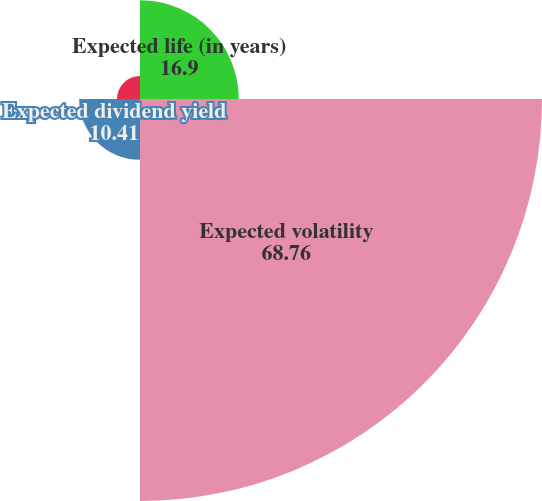<chart> <loc_0><loc_0><loc_500><loc_500><pie_chart><fcel>Expected life (in years)<fcel>Expected volatility<fcel>Expected dividend yield<fcel>Risk-free interest rate<nl><fcel>16.9%<fcel>68.76%<fcel>10.41%<fcel>3.93%<nl></chart> 